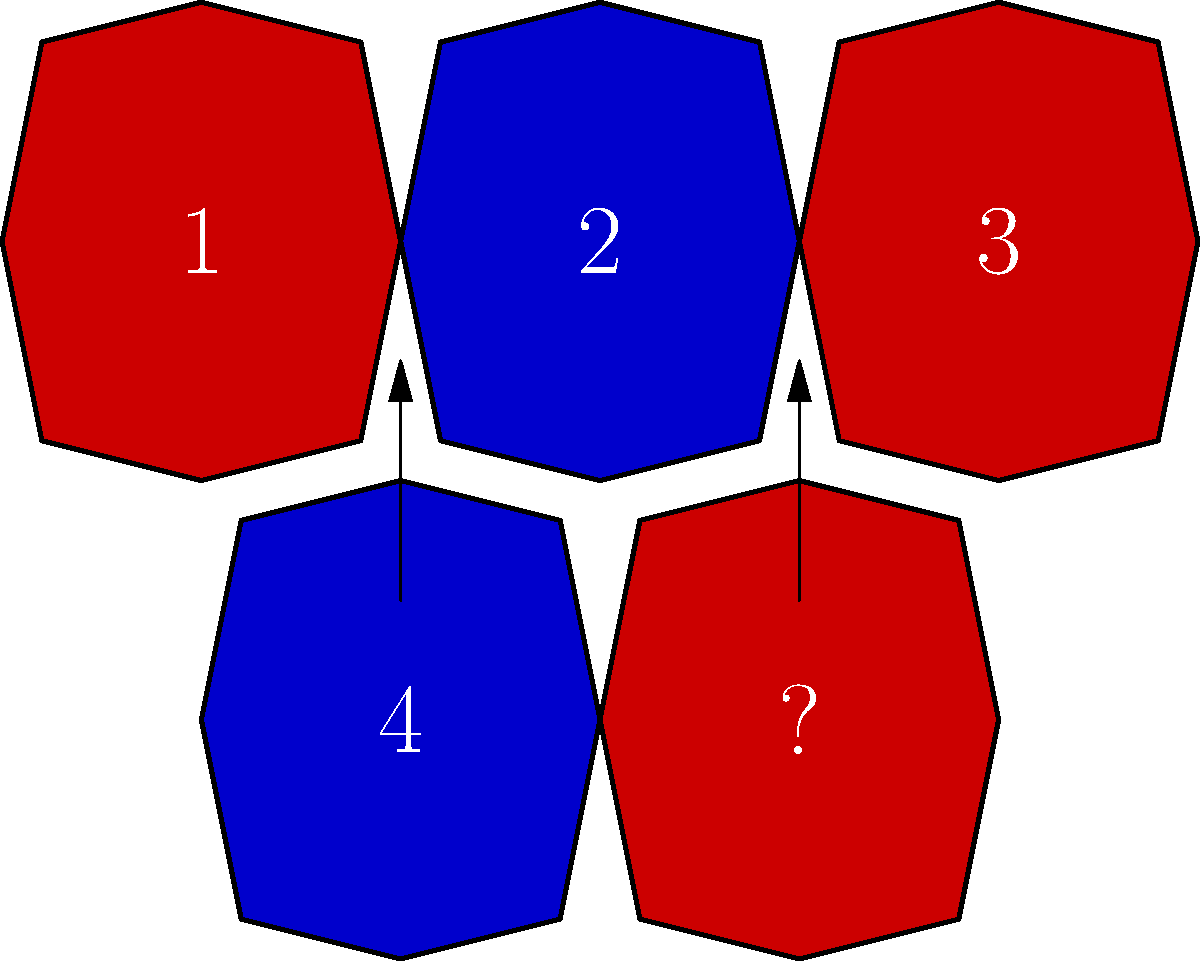Basierend auf dem Muster der Trikotfarben und Nummern, welche Nummer sollte logischerweise im Trikot mit dem Fragezeichen stehen? Um diese Frage zu beantworten, müssen wir das Muster in der Reihenfolge der Trikots und ihrer Nummern analysieren:

1. Wir sehen eine Abfolge von rot (1), blau (2), rot (3), blau (4), rot (?).
2. Die Farben wechseln sich regelmäßig ab: rot, blau, rot, blau, rot.
3. Bei den Nummern erkennen wir eine aufsteigende Reihenfolge: 1, 2, 3, 4.
4. Basierend auf dieser Logik sollte die nächste Nummer in der Sequenz 5 sein.

Die Kombination aus der Farbabfolge (das letzte Trikot ist rot) und der aufsteigenden Nummerierung führt uns zu dem Schluss, dass das rote Trikot mit dem Fragezeichen logischerweise die Nummer 5 tragen sollte.
Answer: 5 